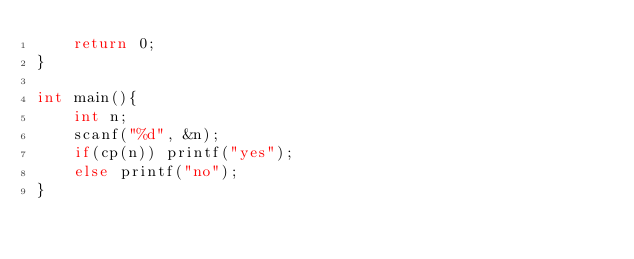Convert code to text. <code><loc_0><loc_0><loc_500><loc_500><_C++_>	return 0;
}

int main(){
	int n;
	scanf("%d", &n);
	if(cp(n)) printf("yes");
	else printf("no");
}
</code> 